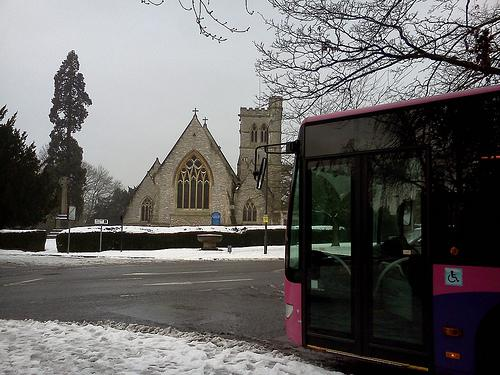Question: what building is in this picture?
Choices:
A. A cathedral.
B. A school.
C. A bank.
D. An apartment.
Answer with the letter. Answer: A Question: where did the bus stop?
Choices:
A. At the school.
B. At the terminal.
C. At the bus station.
D. On the street.
Answer with the letter. Answer: D Question: how many doors are on the bus?
Choices:
A. 6.
B. 4.
C. 2.
D. 8.
Answer with the letter. Answer: C Question: how many crosses are visible in the picture?
Choices:
A. 4.
B. 2.
C. 5.
D. 8.
Answer with the letter. Answer: B Question: where is the handicap sign located?
Choices:
A. On the parking stall.
B. On the train.
C. On the bus.
D. On the placard.
Answer with the letter. Answer: C Question: what color is the sky?
Choices:
A. Blue.
B. White.
C. Grey.
D. Yellow.
Answer with the letter. Answer: C 